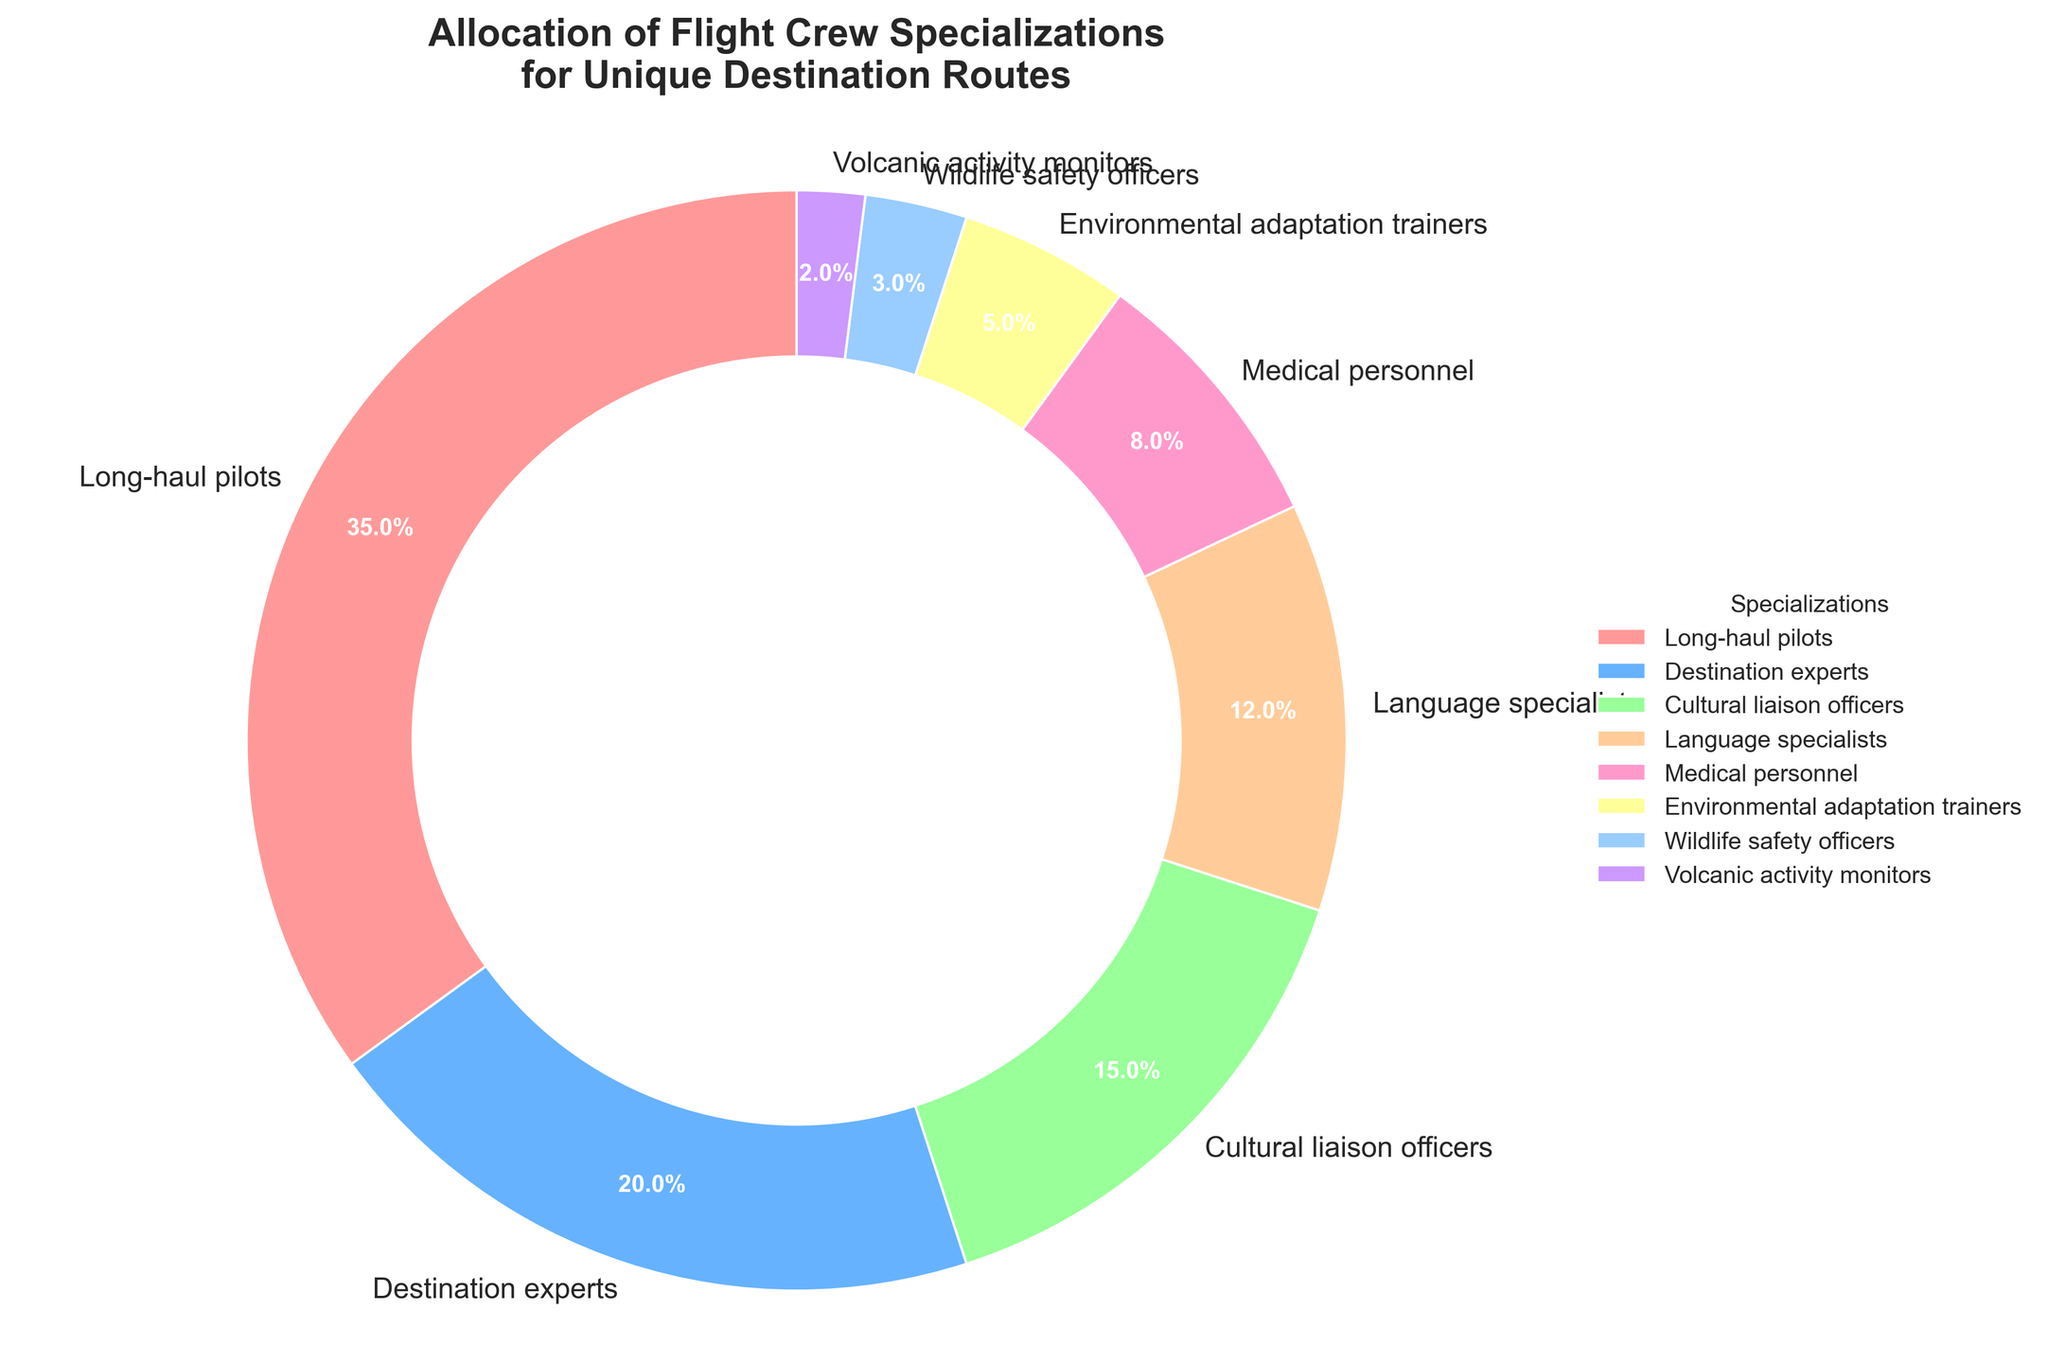What is the largest segment in the pie chart? The largest segment in the pie chart is identified visually as the one occupying the most space. It has a percentage of 35% and is labeled "Long-haul pilots".
Answer: Long-haul pilots Which specialization has the smallest allocation? The smallest segment can be found by identifying the piece of the pie chart with the smallest area. It is labeled "Volcanic activity monitors" with 2%.
Answer: Volcanic activity monitors How much larger is the percentage of Long-haul pilots compared to Language specialists? First, locate the Long-haul pilots segment (35%) and the Language specialists segment (12%). Then, subtract the percentage of Language specialists from Long-haul pilots: 35% - 12% = 23%.
Answer: 23% What is the combined percentage of Destination experts and Cultural liaison officers? Find the segments for Destination experts (20%) and Cultural liaison officers (15%), then add them together: 20% + 15% = 35%.
Answer: 35% How many specializations have a percentage allocation above 10%? Identify and count the specializations with percentages greater than 10%: Long-haul pilots (35%), Destination experts (20%), Cultural liaison officers (15%), and Language specialists (12%). There are four such specializations.
Answer: 4 Which segment is represented in green? The colors used in the pie chart correspond to specializations. The green segment is labeled "Language specialists".
Answer: Language specialists Is the percentage of Medical personnel greater than the combined percentage of Environmental adaptation trainers and Volcanic activity monitors? Compare the percentage of Medical personnel (8%) with the combined percentage of Environmental adaptation trainers (5%) and Volcanic activity monitors (2%): 5% + 2% = 7%. Since 8% is greater than 7%, Medical personnel has a higher percentage.
Answer: Yes Which has a larger proportion: Medical personnel or Wildlife safety officers? Compare the segment sizes for Medical personnel (8%) and Wildlife safety officers (3%). Medical personnel has a larger proportion.
Answer: Medical personnel What is the average percentage of the Environmental adaptation trainers and Wildlife safety officers' allocations? Add the percentages of Environmental adaptation trainers (5%) and Wildlife safety officers (3%) and divide by 2 to find the average: (5% + 3%) / 2 = 4%.
Answer: 4% Identify all specializations occupying less than 5% of the chart. Find all segments that are labeled with percentages less than 5%. These are Wildlife safety officers (3%) and Volcanic activity monitors (2%).
Answer: Wildlife safety officers, Volcanic activity monitors 